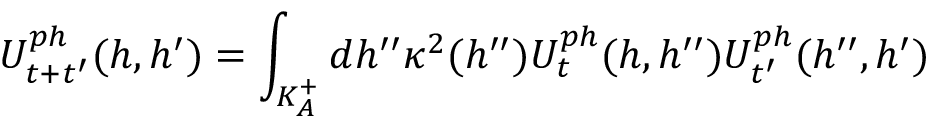<formula> <loc_0><loc_0><loc_500><loc_500>U _ { t + t ^ { \prime } } ^ { p h } ( h , h ^ { \prime } ) = \int _ { K _ { A } ^ { + } } d h ^ { \prime \prime } \kappa ^ { 2 } ( h ^ { \prime \prime } ) U _ { t } ^ { p h } ( h , h ^ { \prime \prime } ) U _ { t ^ { \prime } } ^ { p h } ( h ^ { \prime \prime } , h ^ { \prime } )</formula> 